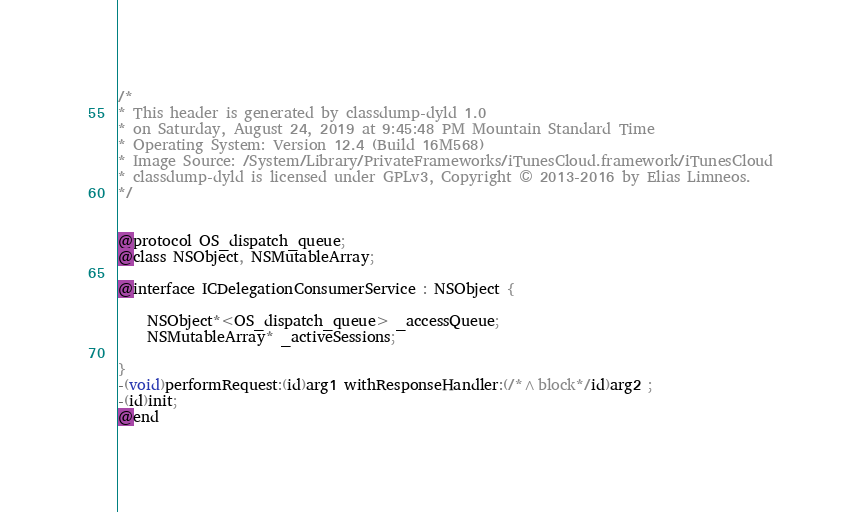<code> <loc_0><loc_0><loc_500><loc_500><_C_>/*
* This header is generated by classdump-dyld 1.0
* on Saturday, August 24, 2019 at 9:45:48 PM Mountain Standard Time
* Operating System: Version 12.4 (Build 16M568)
* Image Source: /System/Library/PrivateFrameworks/iTunesCloud.framework/iTunesCloud
* classdump-dyld is licensed under GPLv3, Copyright © 2013-2016 by Elias Limneos.
*/


@protocol OS_dispatch_queue;
@class NSObject, NSMutableArray;

@interface ICDelegationConsumerService : NSObject {

	NSObject*<OS_dispatch_queue> _accessQueue;
	NSMutableArray* _activeSessions;

}
-(void)performRequest:(id)arg1 withResponseHandler:(/*^block*/id)arg2 ;
-(id)init;
@end

</code> 